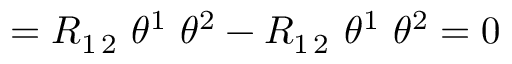<formula> <loc_0><loc_0><loc_500><loc_500>= R _ { 1 \, 2 } \ \theta ^ { 1 } \ \theta ^ { 2 } - R _ { 1 \, 2 } \ \theta ^ { 1 } \ \theta ^ { 2 } = 0</formula> 